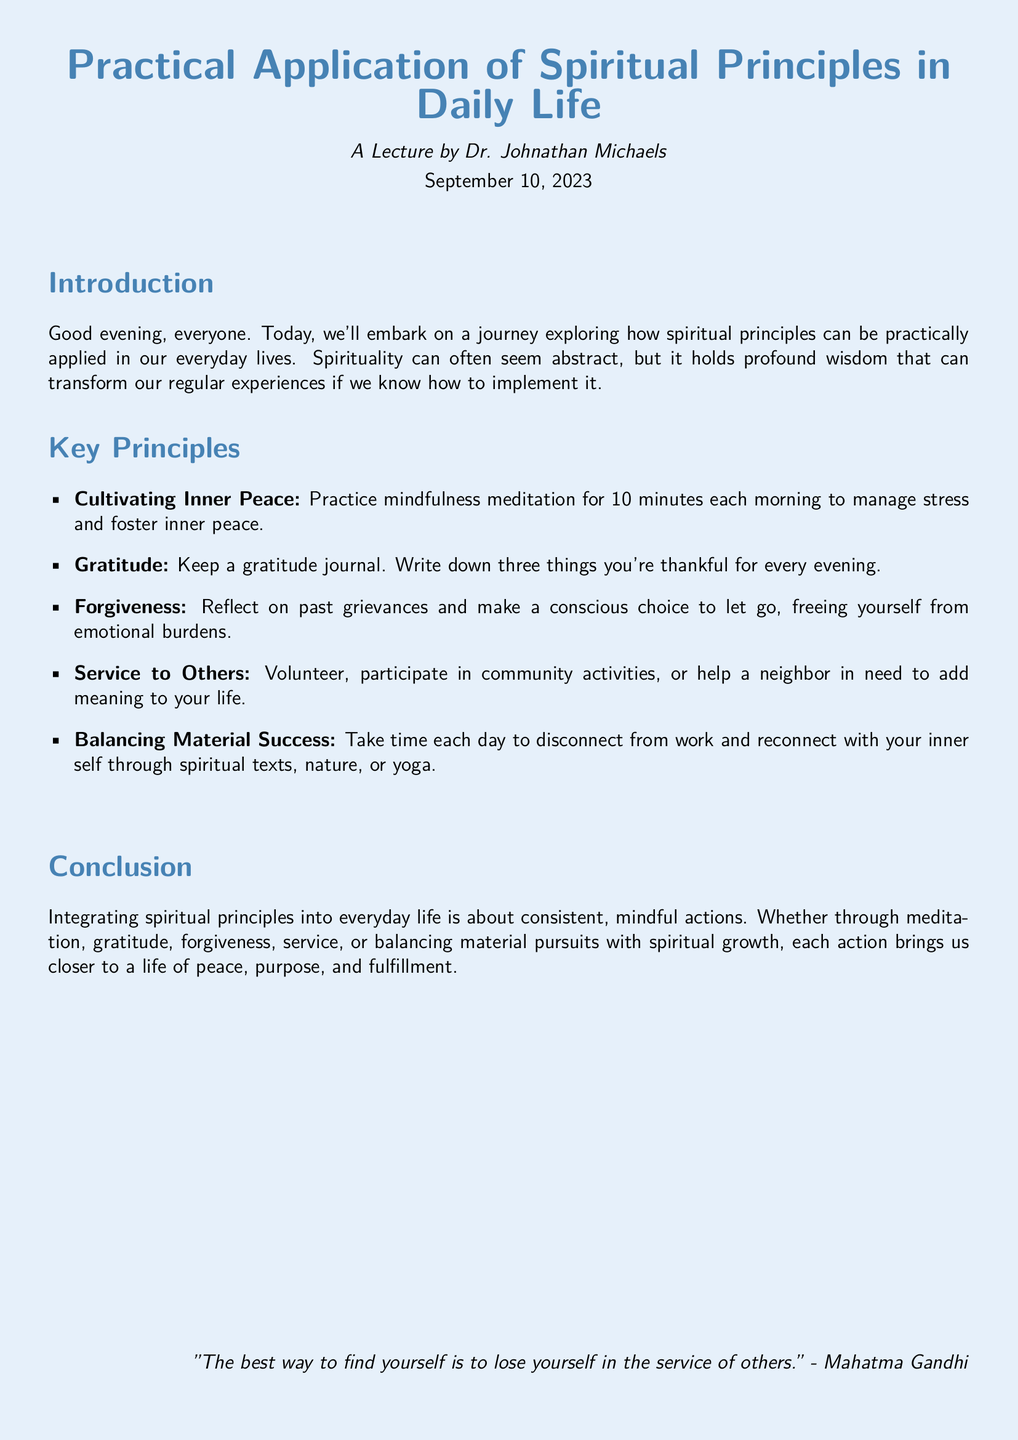What is the title of the lecture? The title of the lecture is stated at the beginning of the document.
Answer: Practical Application of Spiritual Principles in Daily Life Who is the lecturer? The name of the lecturer is mentioned in the introduction section.
Answer: Dr. Johnathan Michaels When was the lecture held? The date of the lecture is indicated in the document.
Answer: September 10, 2023 What is one method to cultivate inner peace? The document specifically mentions a practice for cultivating inner peace in the key principles section.
Answer: Mindfulness meditation How many things should be written in the gratitude journal? The document provides a specific quantity to write down in the gratitude journal.
Answer: Three What is a suggested activity for service to others? The key principles section lists activities that promote service to others.
Answer: Volunteer According to the conclusion, what brings us closer to a life of peace? The conclusion summarizes the actions that contribute to a peaceful life.
Answer: Consistent, mindful actions Which famous figure is quoted at the end of the document? The quote at the end references a well-known figure.
Answer: Mahatma Gandhi 